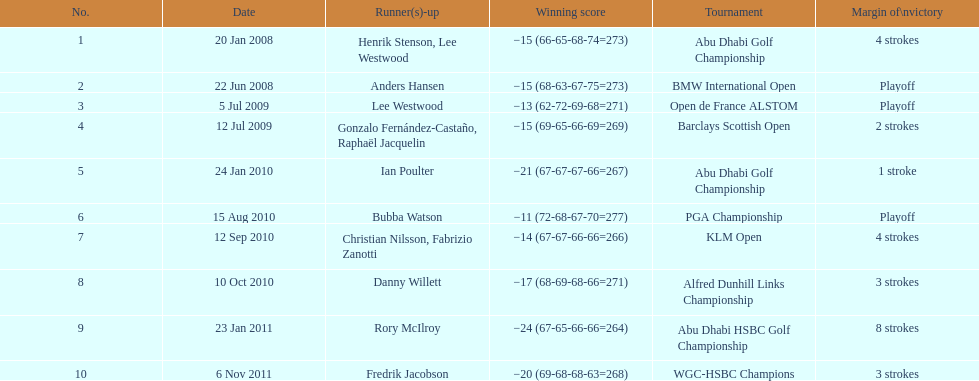How long separated the playoff victory at bmw international open and the 4 stroke victory at the klm open? 2 years. 